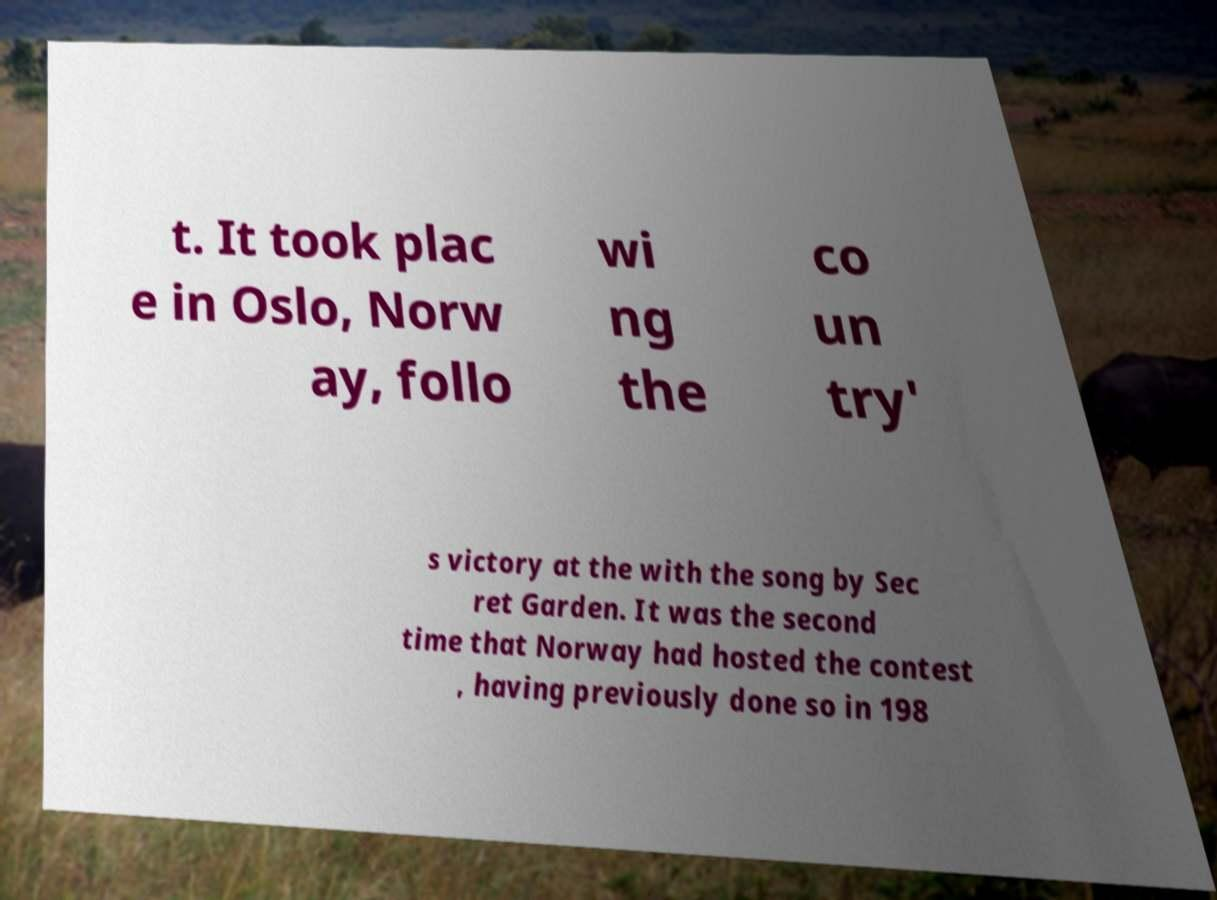There's text embedded in this image that I need extracted. Can you transcribe it verbatim? t. It took plac e in Oslo, Norw ay, follo wi ng the co un try' s victory at the with the song by Sec ret Garden. It was the second time that Norway had hosted the contest , having previously done so in 198 